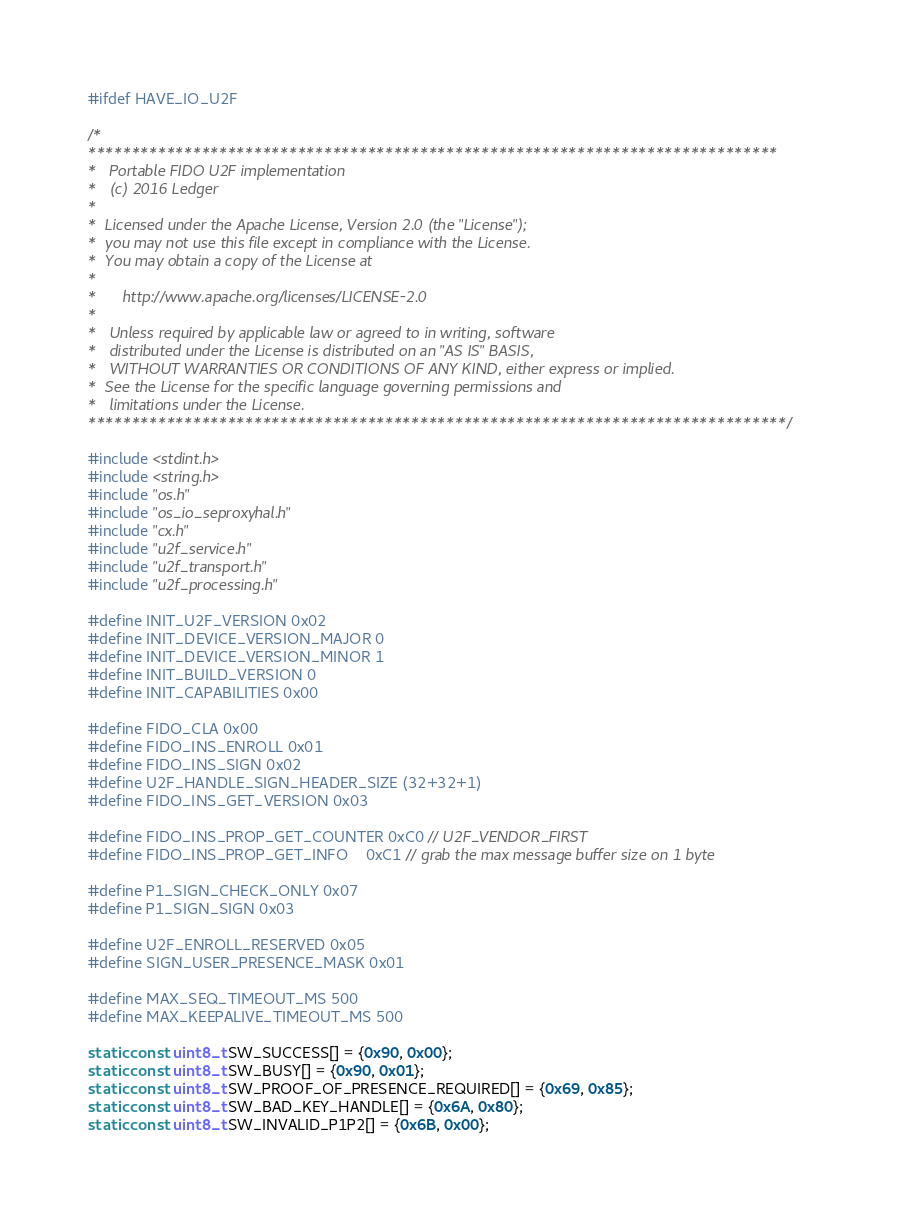Convert code to text. <code><loc_0><loc_0><loc_500><loc_500><_C_>#ifdef HAVE_IO_U2F

/*
*******************************************************************************
*   Portable FIDO U2F implementation
*   (c) 2016 Ledger
*
*  Licensed under the Apache License, Version 2.0 (the "License");
*  you may not use this file except in compliance with the License.
*  You may obtain a copy of the License at
*
*      http://www.apache.org/licenses/LICENSE-2.0
*
*   Unless required by applicable law or agreed to in writing, software
*   distributed under the License is distributed on an "AS IS" BASIS,
*   WITHOUT WARRANTIES OR CONDITIONS OF ANY KIND, either express or implied.
*  See the License for the specific language governing permissions and
*   limitations under the License.
********************************************************************************/

#include <stdint.h>
#include <string.h>
#include "os.h"
#include "os_io_seproxyhal.h"
#include "cx.h"
#include "u2f_service.h"
#include "u2f_transport.h"
#include "u2f_processing.h"

#define INIT_U2F_VERSION 0x02
#define INIT_DEVICE_VERSION_MAJOR 0
#define INIT_DEVICE_VERSION_MINOR 1
#define INIT_BUILD_VERSION 0
#define INIT_CAPABILITIES 0x00

#define FIDO_CLA 0x00
#define FIDO_INS_ENROLL 0x01
#define FIDO_INS_SIGN 0x02
#define U2F_HANDLE_SIGN_HEADER_SIZE (32+32+1)
#define FIDO_INS_GET_VERSION 0x03

#define FIDO_INS_PROP_GET_COUNTER 0xC0 // U2F_VENDOR_FIRST
#define FIDO_INS_PROP_GET_INFO    0xC1 // grab the max message buffer size on 1 byte

#define P1_SIGN_CHECK_ONLY 0x07
#define P1_SIGN_SIGN 0x03

#define U2F_ENROLL_RESERVED 0x05
#define SIGN_USER_PRESENCE_MASK 0x01

#define MAX_SEQ_TIMEOUT_MS 500
#define MAX_KEEPALIVE_TIMEOUT_MS 500

static const uint8_t SW_SUCCESS[] = {0x90, 0x00};
static const uint8_t SW_BUSY[] = {0x90, 0x01};
static const uint8_t SW_PROOF_OF_PRESENCE_REQUIRED[] = {0x69, 0x85};
static const uint8_t SW_BAD_KEY_HANDLE[] = {0x6A, 0x80};
static const uint8_t SW_INVALID_P1P2[] = {0x6B, 0x00};
</code> 